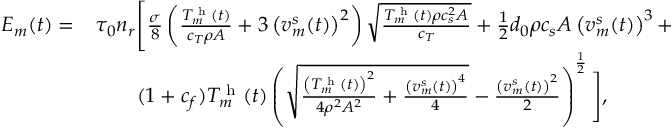<formula> <loc_0><loc_0><loc_500><loc_500>\begin{array} { r l } { E _ { m } ( t ) = } & { \tau _ { 0 } n _ { r } \left [ \frac { \sigma } { 8 } \left ( \frac { T _ { m } ^ { h } ( t ) } { c _ { T } \rho A } + 3 \left ( v _ { m } ^ { s } ( t ) \right ) ^ { 2 } \right ) \sqrt { \frac { T _ { m } ^ { h } ( t ) \rho c _ { s } ^ { 2 } A } { c _ { T } } } + \frac { 1 } { 2 } d _ { 0 } \rho c _ { s } A \left ( v _ { m } ^ { s } ( t ) \right ) ^ { 3 } + } \\ & { \quad ( 1 + c _ { f } ) T _ { m } ^ { h } ( t ) \left ( \sqrt { \frac { \left ( T _ { m } ^ { h } ( t ) \right ) ^ { 2 } } { 4 \rho ^ { 2 } A ^ { 2 } } + \frac { \left ( v _ { m } ^ { s } ( t ) \right ) ^ { 4 } } { 4 } } - \frac { \left ( v _ { m } ^ { s } ( t ) \right ) ^ { 2 } } { 2 } \right ) ^ { \frac { 1 } { 2 } } \right ] , } \end{array}</formula> 